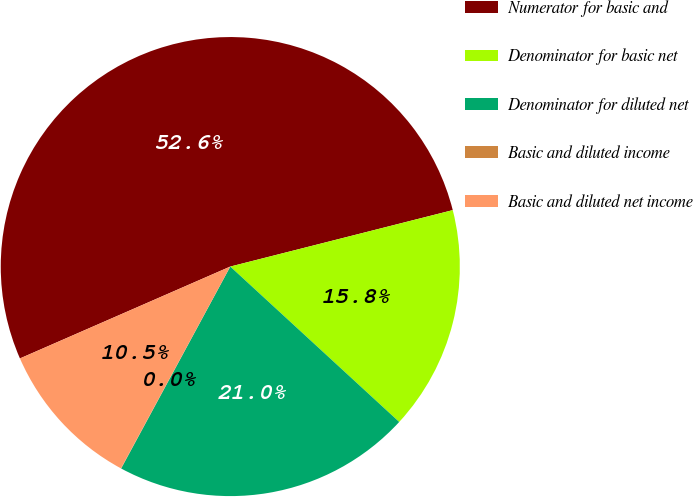<chart> <loc_0><loc_0><loc_500><loc_500><pie_chart><fcel>Numerator for basic and<fcel>Denominator for basic net<fcel>Denominator for diluted net<fcel>Basic and diluted income<fcel>Basic and diluted net income<nl><fcel>52.6%<fcel>15.79%<fcel>21.05%<fcel>0.02%<fcel>10.54%<nl></chart> 